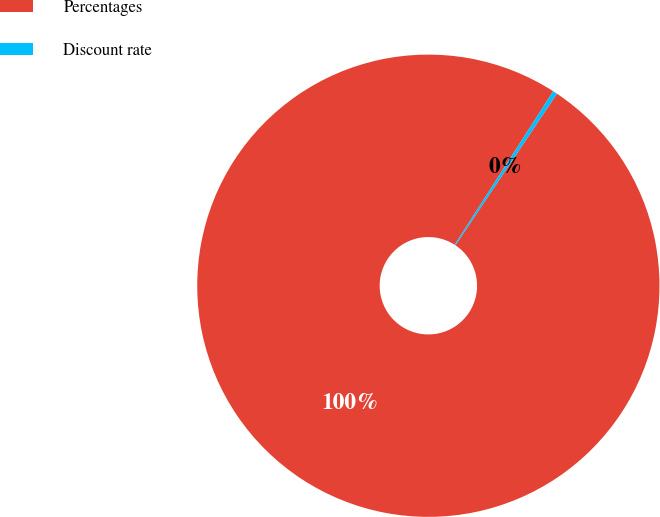<chart> <loc_0><loc_0><loc_500><loc_500><pie_chart><fcel>Percentages<fcel>Discount rate<nl><fcel>99.69%<fcel>0.31%<nl></chart> 